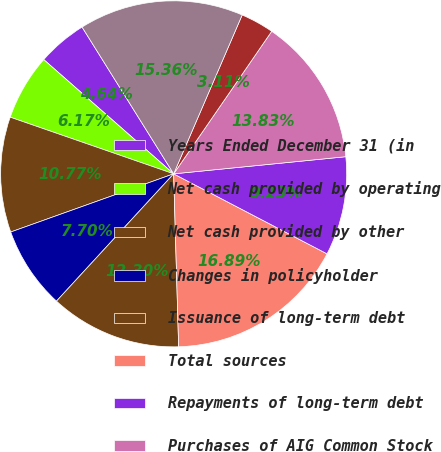<chart> <loc_0><loc_0><loc_500><loc_500><pie_chart><fcel>Years Ended December 31 (in<fcel>Net cash provided by operating<fcel>Net cash provided by other<fcel>Changes in policyholder<fcel>Issuance of long-term debt<fcel>Total sources<fcel>Repayments of long-term debt<fcel>Purchases of AIG Common Stock<fcel>Dividends paid<fcel>Total uses<nl><fcel>4.64%<fcel>6.17%<fcel>10.77%<fcel>7.7%<fcel>12.3%<fcel>16.89%<fcel>9.23%<fcel>13.83%<fcel>3.11%<fcel>15.36%<nl></chart> 